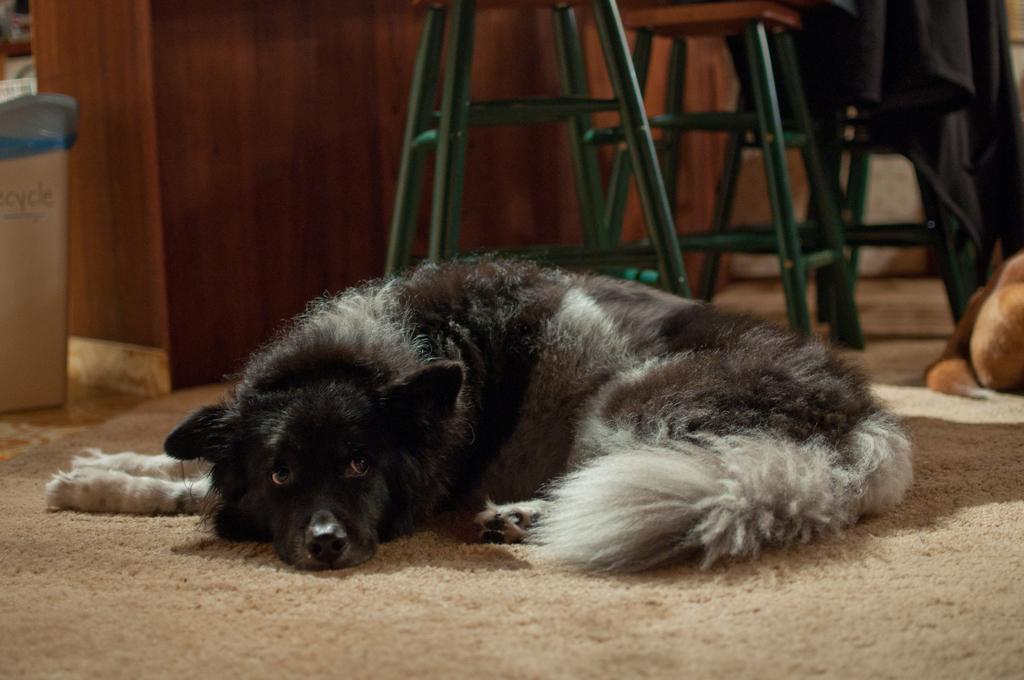Can you describe this image briefly? In this image in the center there is a dog laying on the floor which is black and white in colour. On the right side there is an object which is brown in colour. In the background there are stools and there is a cloth which is black in colour. On the left side there is a box with some text written on it and there is an object which is brown in colour in the background. 